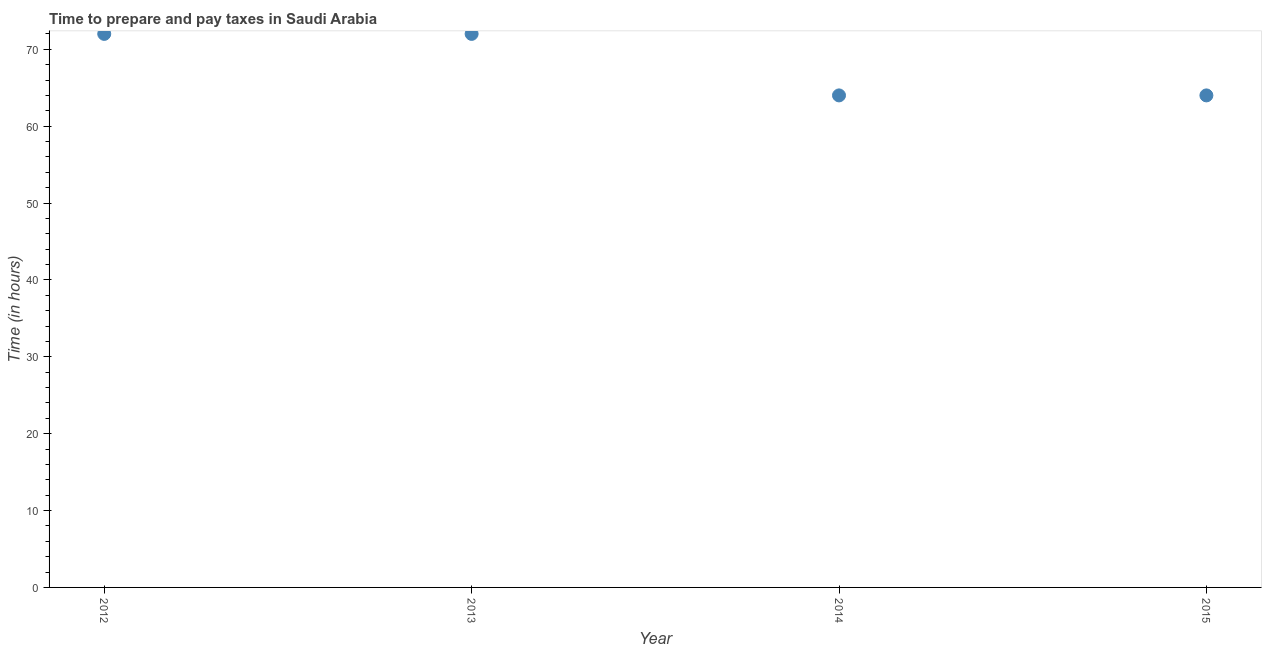What is the time to prepare and pay taxes in 2015?
Keep it short and to the point. 64. Across all years, what is the maximum time to prepare and pay taxes?
Provide a short and direct response. 72. Across all years, what is the minimum time to prepare and pay taxes?
Offer a terse response. 64. In which year was the time to prepare and pay taxes maximum?
Provide a short and direct response. 2012. In which year was the time to prepare and pay taxes minimum?
Offer a very short reply. 2014. What is the sum of the time to prepare and pay taxes?
Ensure brevity in your answer.  272. What is the difference between the time to prepare and pay taxes in 2013 and 2015?
Your answer should be very brief. 8. What is the average time to prepare and pay taxes per year?
Provide a short and direct response. 68. What is the median time to prepare and pay taxes?
Your answer should be very brief. 68. What is the ratio of the time to prepare and pay taxes in 2013 to that in 2015?
Provide a succinct answer. 1.12. Is the time to prepare and pay taxes in 2014 less than that in 2015?
Provide a succinct answer. No. Is the difference between the time to prepare and pay taxes in 2012 and 2015 greater than the difference between any two years?
Give a very brief answer. Yes. What is the difference between the highest and the lowest time to prepare and pay taxes?
Your answer should be compact. 8. In how many years, is the time to prepare and pay taxes greater than the average time to prepare and pay taxes taken over all years?
Offer a terse response. 2. How many years are there in the graph?
Provide a short and direct response. 4. Are the values on the major ticks of Y-axis written in scientific E-notation?
Offer a very short reply. No. What is the title of the graph?
Your answer should be very brief. Time to prepare and pay taxes in Saudi Arabia. What is the label or title of the X-axis?
Your answer should be very brief. Year. What is the label or title of the Y-axis?
Your response must be concise. Time (in hours). What is the Time (in hours) in 2012?
Provide a succinct answer. 72. What is the Time (in hours) in 2014?
Offer a very short reply. 64. What is the Time (in hours) in 2015?
Offer a very short reply. 64. What is the difference between the Time (in hours) in 2013 and 2014?
Your answer should be compact. 8. What is the difference between the Time (in hours) in 2013 and 2015?
Your answer should be very brief. 8. What is the ratio of the Time (in hours) in 2012 to that in 2013?
Give a very brief answer. 1. What is the ratio of the Time (in hours) in 2013 to that in 2014?
Provide a short and direct response. 1.12. 